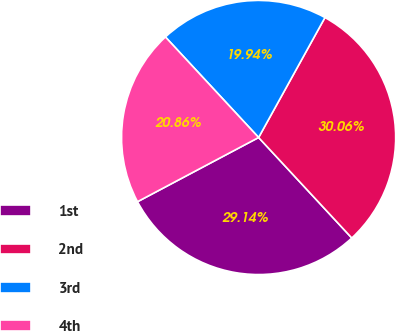Convert chart. <chart><loc_0><loc_0><loc_500><loc_500><pie_chart><fcel>1st<fcel>2nd<fcel>3rd<fcel>4th<nl><fcel>29.14%<fcel>30.06%<fcel>19.94%<fcel>20.86%<nl></chart> 